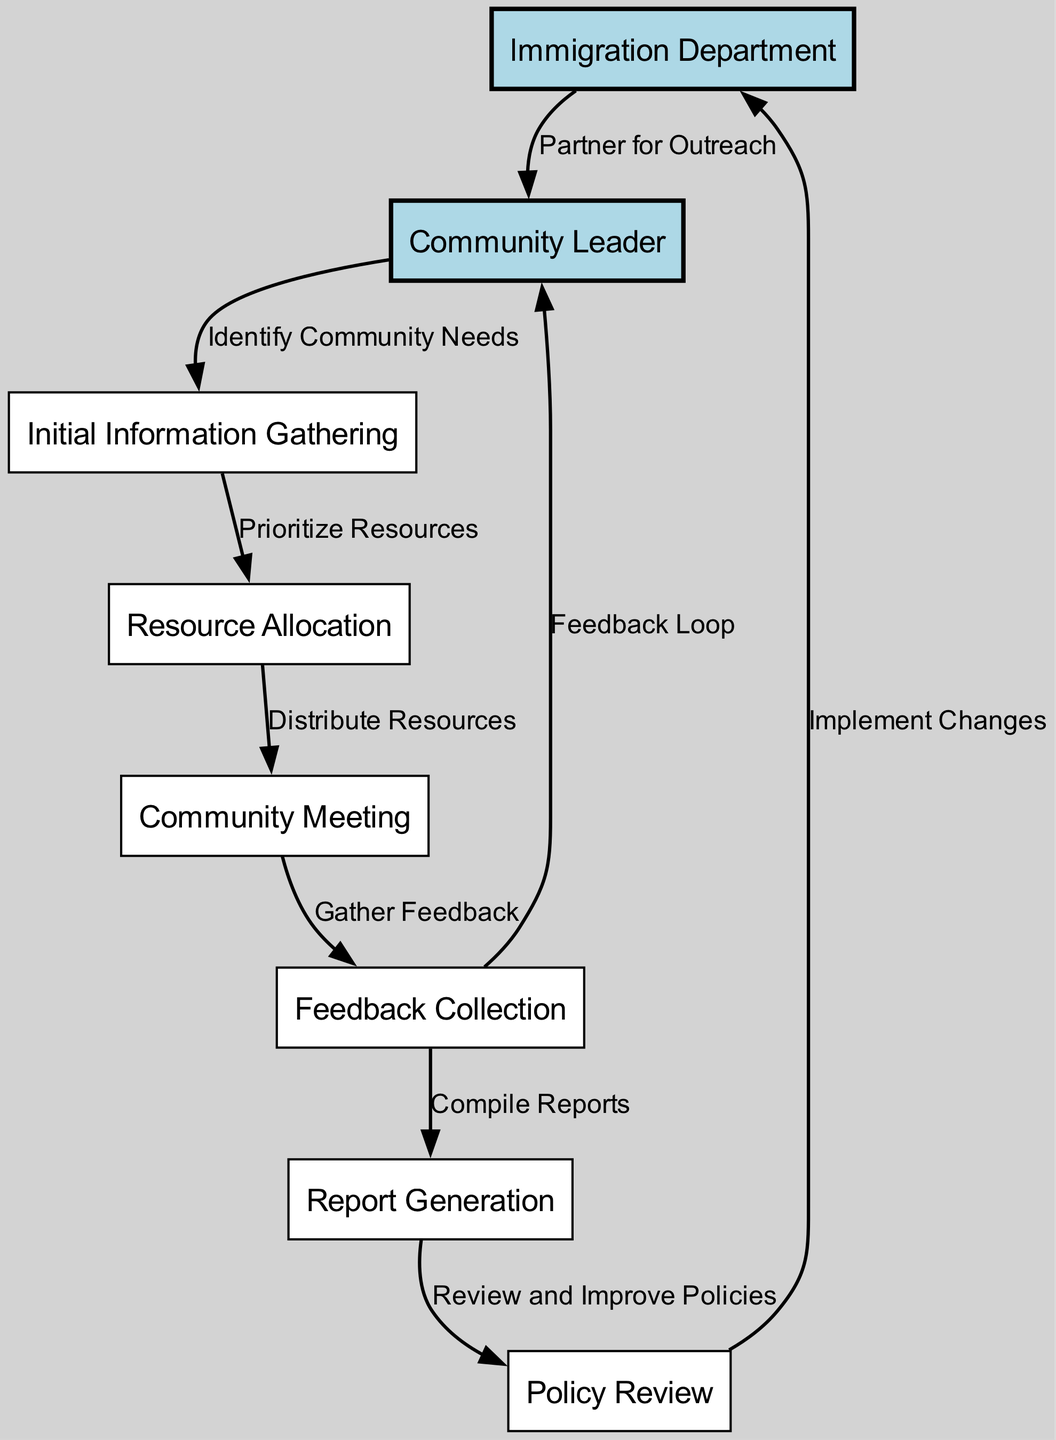What are the two main entities in the collaboration workflow? The diagram identifies "Immigration Department" and "Community Leader" as the two main entities, represented as nodes at the top of the workflow chart.
Answer: Immigration Department and Community Leader How many nodes are in the diagram? By counting each unique node listed in the provided data, we find there are eight different nodes representing various steps in the workflow.
Answer: Eight What is the role of the "Community Leader" in the workflow? The "Community Leader" has a specific role in the workflow that involves identifying community needs, which indicates they gather information necessary for further actions.
Answer: Identify Community Needs What action follows the "Feedback Collection"? After "Feedback Collection," the next action shown in the workflow is "Report Generation," indicating that collected feedback is used to compile reports for further review.
Answer: Report Generation How does the "Immigration Department" contribute to the workflow? The "Immigration Department" engages as a partner for outreach, indicating a collaborative approach right at the initiation of the workflow process with the community leader.
Answer: Partner for Outreach What feedback loop is depicted in the diagram? The feedback loop involves the "Feedback Collection" node directing feedback back to the "Community Leader," suggesting that feedback is communicated back for improved understanding and future actions.
Answer: Feedback Loop Which step prioritizes resources based on community needs? The step that follows from "Information Gathering" to the next step is "Resource Allocation," which emphasizes the need to prioritize resources based on the gathered information about community necessities.
Answer: Prioritize Resources After "Report Generation," what is the next step indicated in the workflow? Upon completion of "Report Generation," the subsequent step is "Policy Review," indicating that the generated reports are assessed for policy improvements and adjustments.
Answer: Policy Review What is the final action taken by the "Immigration Department"? The workflow indicates that the final action taken by the "Immigration Department" is "Implement Changes," highlighting their role in applying the improvements reviewed from feedback.
Answer: Implement Changes 